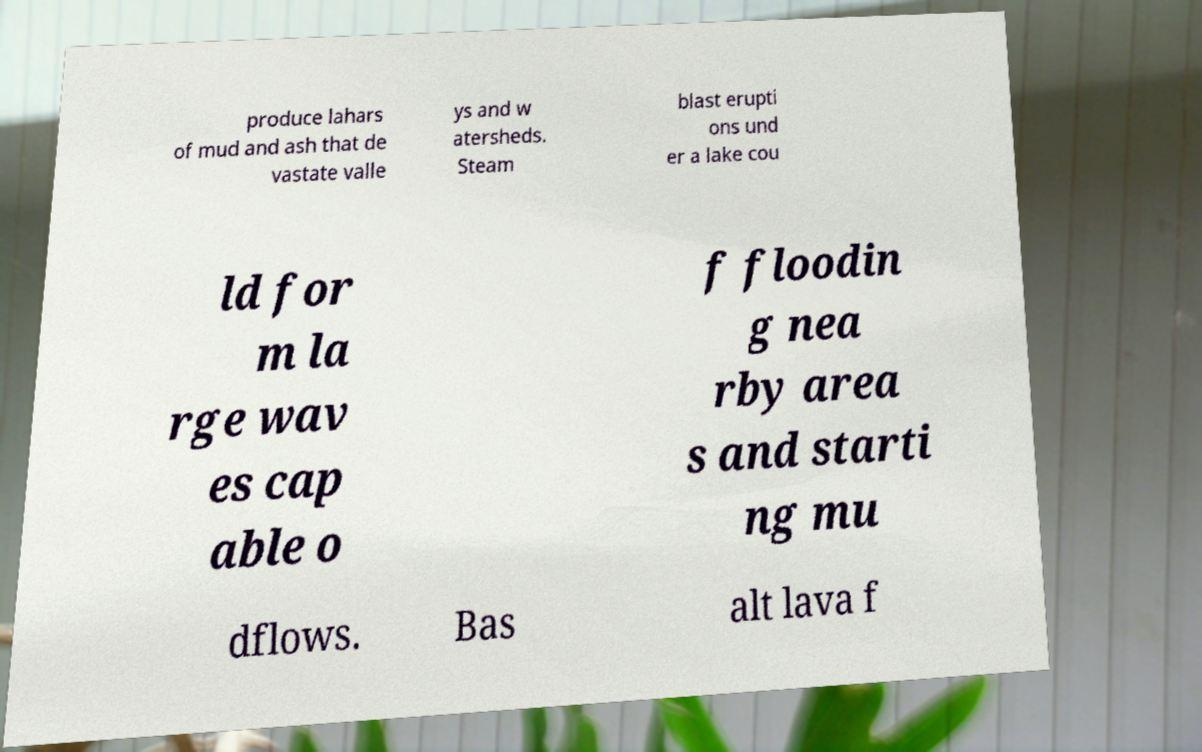Can you accurately transcribe the text from the provided image for me? produce lahars of mud and ash that de vastate valle ys and w atersheds. Steam blast erupti ons und er a lake cou ld for m la rge wav es cap able o f floodin g nea rby area s and starti ng mu dflows. Bas alt lava f 